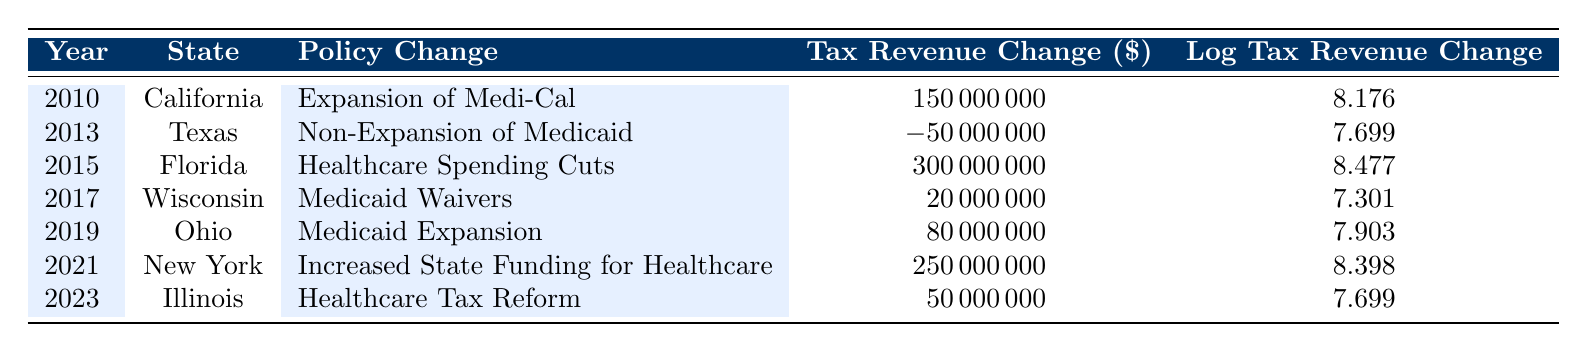What was the tax revenue change for California in 2010? The table shows that in 2010, the tax revenue change for California was listed as 150000000 dollars.
Answer: 150000000 Which state saw a tax revenue decrease due to non-expansion of Medicaid? The data indicates that Texas experienced a tax revenue decrease of 50000000 dollars due to the non-expansion of Medicaid in 2013.
Answer: Texas What is the average tax revenue change from 2015 to 2023? To find the average, we first sum the tax revenue changes from each applicable year: 300000000 (Florida 2015) + 80000000 (Ohio 2019) + 250000000 (New York 2021) + 50000000 (Illinois 2023) = 680000000. Then, divide by 4 (number of data points): 680000000 / 4 = 170000000.
Answer: 170000000 Did any state have a tax revenue change greater than 200 million dollars from 2010 to 2023? Yes, Florida had a tax revenue change of 300 million dollars in 2015, which is greater than 200 million.
Answer: Yes What was the tax revenue change for the Medicaid Expansion in Ohio compared to the tax revenue change for the Healthcare Spending Cuts in Florida? The tax revenue change for Ohio's Medicaid Expansion was 80000000 dollars, while for Florida's Healthcare Spending Cuts it was 300000000 dollars. The difference is calculated as 300000000 - 80000000 = 220000000, indicating Florida had a higher tax revenue change.
Answer: Florida had a higher tax revenue change by 220 million 